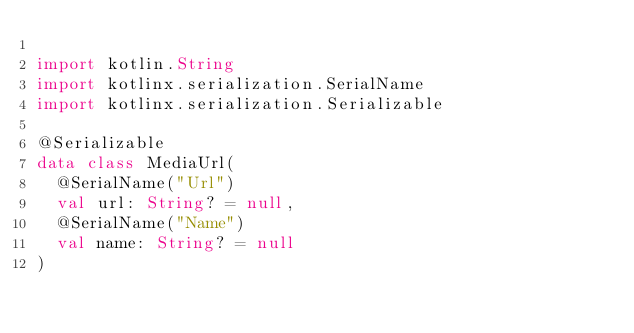<code> <loc_0><loc_0><loc_500><loc_500><_Kotlin_>
import kotlin.String
import kotlinx.serialization.SerialName
import kotlinx.serialization.Serializable

@Serializable
data class MediaUrl(
	@SerialName("Url")
	val url: String? = null,
	@SerialName("Name")
	val name: String? = null
)
</code> 